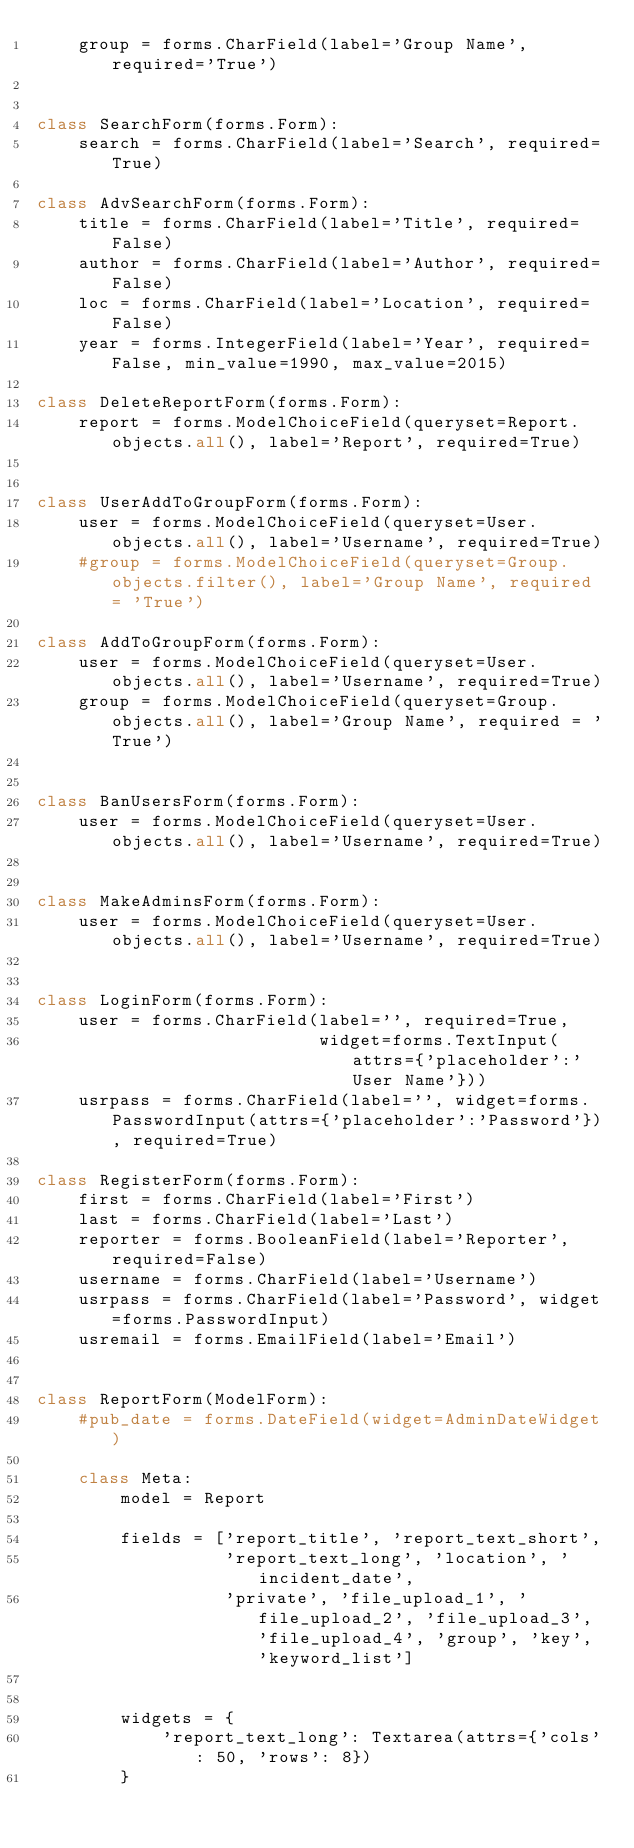Convert code to text. <code><loc_0><loc_0><loc_500><loc_500><_Python_>    group = forms.CharField(label='Group Name', required='True')


class SearchForm(forms.Form):
    search = forms.CharField(label='Search', required=True)

class AdvSearchForm(forms.Form):
    title = forms.CharField(label='Title', required=False)
    author = forms.CharField(label='Author', required=False)
    loc = forms.CharField(label='Location', required=False)
    year = forms.IntegerField(label='Year', required=False, min_value=1990, max_value=2015)

class DeleteReportForm(forms.Form):
    report = forms.ModelChoiceField(queryset=Report.objects.all(), label='Report', required=True)


class UserAddToGroupForm(forms.Form):
    user = forms.ModelChoiceField(queryset=User.objects.all(), label='Username', required=True)
    #group = forms.ModelChoiceField(queryset=Group.objects.filter(), label='Group Name', required = 'True')

class AddToGroupForm(forms.Form):
    user = forms.ModelChoiceField(queryset=User.objects.all(), label='Username', required=True)
    group = forms.ModelChoiceField(queryset=Group.objects.all(), label='Group Name', required = 'True')


class BanUsersForm(forms.Form):
    user = forms.ModelChoiceField(queryset=User.objects.all(), label='Username', required=True)


class MakeAdminsForm(forms.Form):
    user = forms.ModelChoiceField(queryset=User.objects.all(), label='Username', required=True)


class LoginForm(forms.Form):
    user = forms.CharField(label='', required=True,
                           widget=forms.TextInput(attrs={'placeholder':'User Name'}))
    usrpass = forms.CharField(label='', widget=forms.PasswordInput(attrs={'placeholder':'Password'}), required=True)

class RegisterForm(forms.Form):
    first = forms.CharField(label='First')
    last = forms.CharField(label='Last')
    reporter = forms.BooleanField(label='Reporter', required=False)
    username = forms.CharField(label='Username')
    usrpass = forms.CharField(label='Password', widget=forms.PasswordInput)
    usremail = forms.EmailField(label='Email')


class ReportForm(ModelForm):
    #pub_date = forms.DateField(widget=AdminDateWidget)

    class Meta:
        model = Report

        fields = ['report_title', 'report_text_short',
                  'report_text_long', 'location', 'incident_date',
                  'private', 'file_upload_1', 'file_upload_2', 'file_upload_3', 'file_upload_4', 'group', 'key', 'keyword_list']


        widgets = {
            'report_text_long': Textarea(attrs={'cols': 50, 'rows': 8})
        }
</code> 